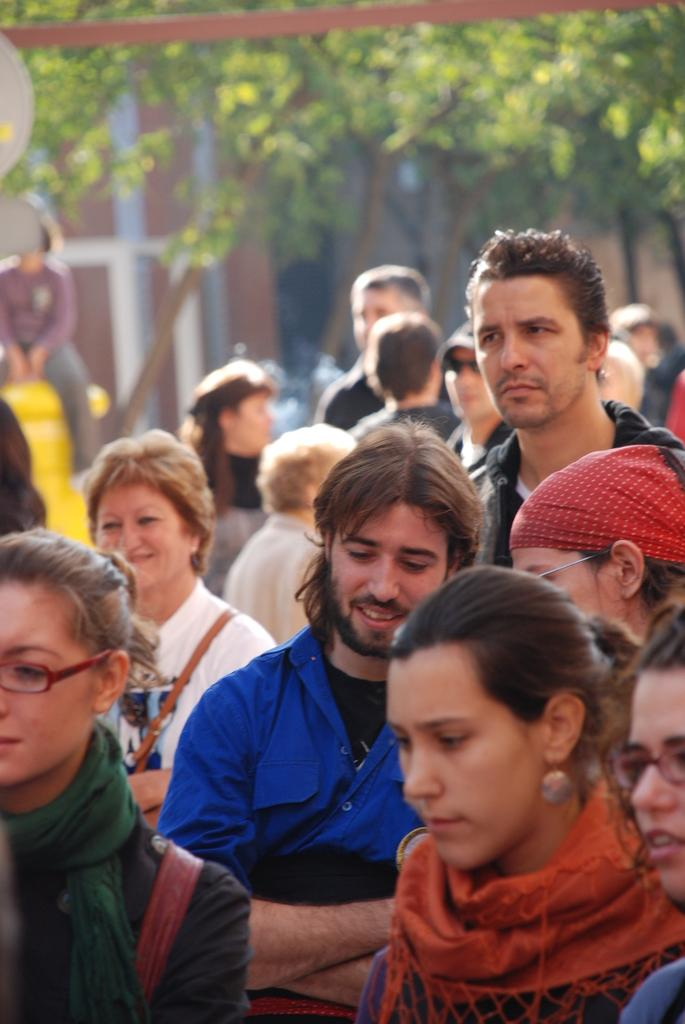How many people are in the image? There is a group of people in the image. Can you describe the position of one of the people? There is a person sitting on the left side of the image. What can be seen in the background of the image? There are trees and a building in the background of the image. What object is visible at the top of the image? There is a wood stick visible at the top of the image. What type of rose can be seen in the image? There is no rose present in the image. Can you describe the texture of the yarn used by the person sitting on the left side of the image? There is no yarn present in the image, and the person sitting on the left side is not shown using any yarn. 